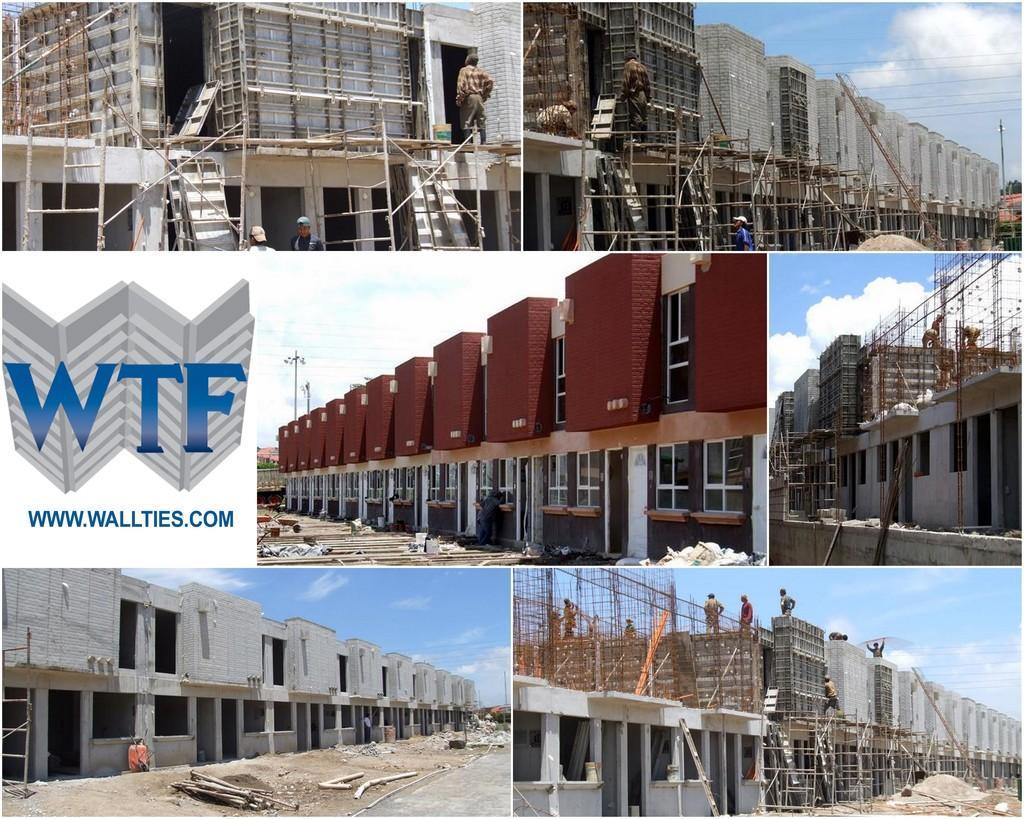How would you summarize this image in a sentence or two? In this picture I can see collage of different pictures, I can see pictures of under construction buildings and I can see few workers in the images and I can see text on the left side of the picture and I can see a blue cloudy sky in all the pictures. 